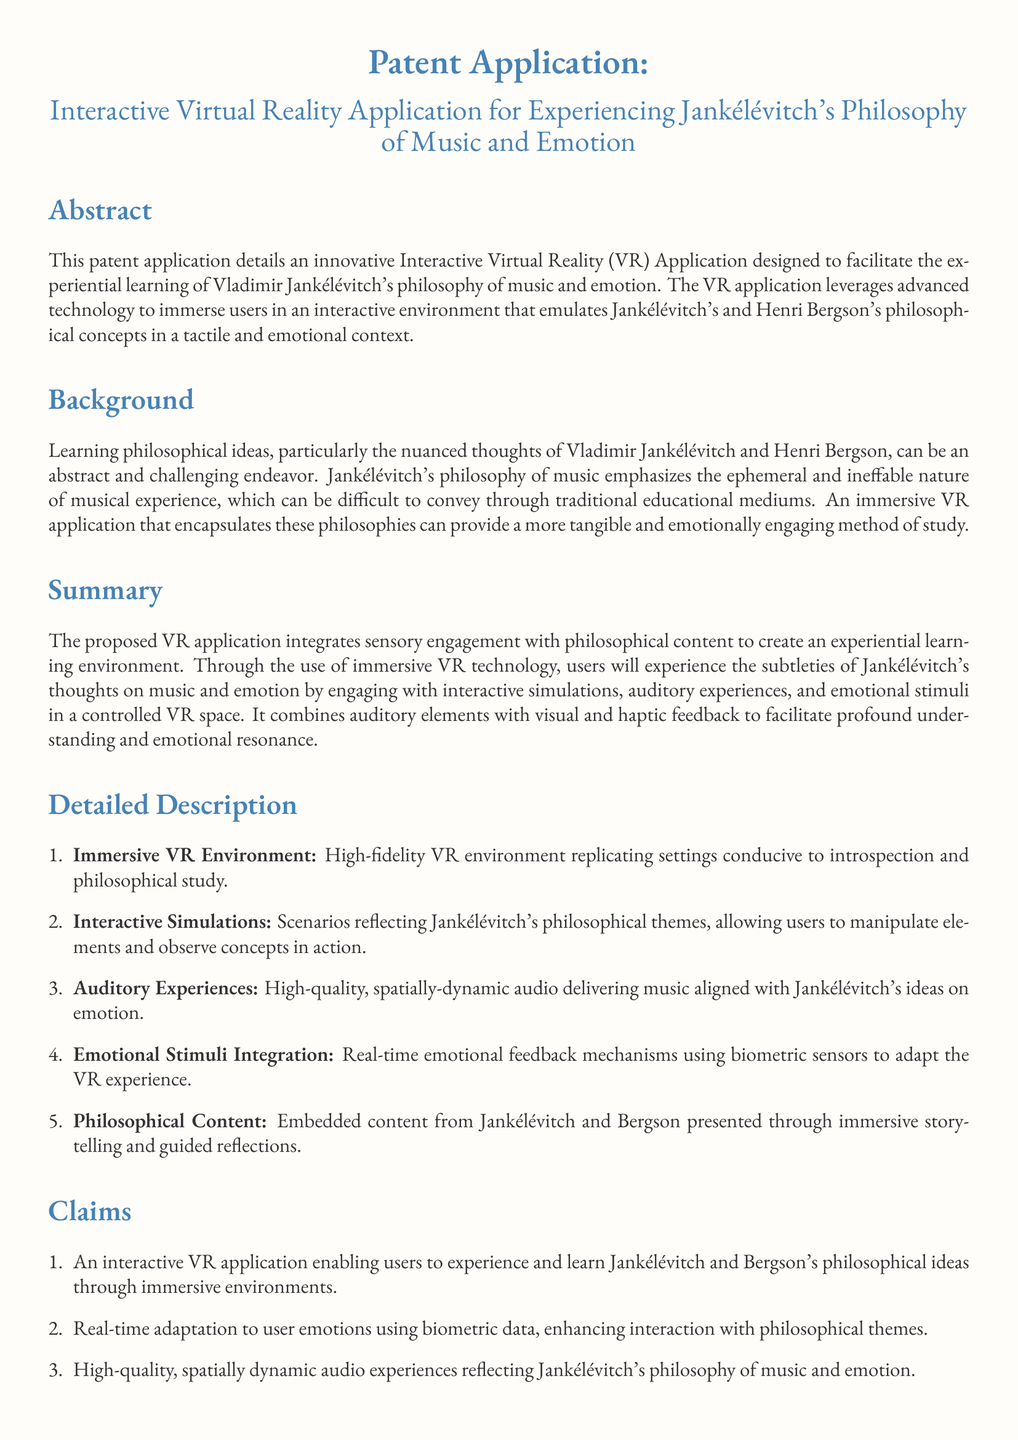What is the title of the patent application? The title of the patent application is stated at the beginning of the document.
Answer: Interactive Virtual Reality Application for Experiencing Jankélévitch's Philosophy of Music and Emotion What are the two philosophers referenced in the application? The document mentions two philosophers whose ideas are integrated into the application.
Answer: Jankélévitch and Bergson How many claims are made in the application? The number of claims can be found in the 'Claims' section of the document.
Answer: Five What is the main purpose of the VR application? The purpose of the application is outlined in the abstract.
Answer: Facilitate the experiential learning of Vladimir Jankélévitch's philosophy of music and emotion What type of experiences does the application include? The detailed description lists various components of the VR application.
Answer: Immersive VR Environment, Interactive Simulations, Auditory Experiences, Emotional Stimuli Integration, Philosophical Content Which technology is used to adapt the experience in real-time? The method for real-time adaptation is mentioned in the claims section.
Answer: Biometric data What aspect of music does Jankélévitch's philosophy emphasize? The background section provides insights into the focus of Jankélévitch's philosophy.
Answer: Ephemeral and ineffable nature of musical experience What type of audio experiences are included in the application? The document specifies the quality and nature of the audio experiences under 'Auditory Experiences.'
Answer: High-quality, spatially-dynamic audio What is the role of emotional stimuli in the VR experience? The detailed description explains the interaction between emotional feedback and the VR environment.
Answer: Adapt the VR experience 